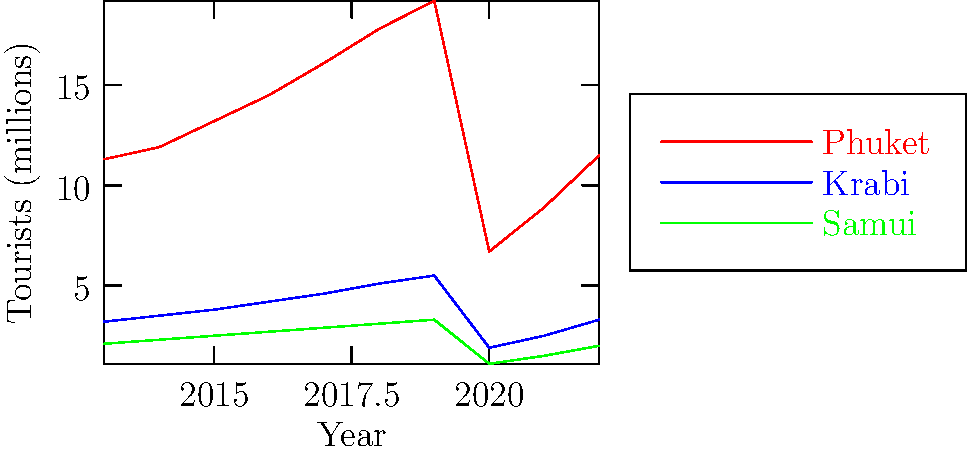Based on the tourism trends shown in the line graph for Thailand's coastal regions over the past decade, which destination appears to be recovering the fastest in terms of tourist numbers following the significant drop in 2020? To determine which destination is recovering the fastest after the 2020 drop, we need to analyze the slopes of the lines from 2020 to 2022 for each destination:

1. Phuket:
   - 2020: 6.7 million tourists
   - 2022: 11.5 million tourists
   - Increase: 4.8 million over 2 years
   - Rate of increase: 2.4 million per year

2. Krabi:
   - 2020: 1.9 million tourists
   - 2022: 3.3 million tourists
   - Increase: 1.4 million over 2 years
   - Rate of increase: 0.7 million per year

3. Samui:
   - 2020: 1.1 million tourists
   - 2022: 2.0 million tourists
   - Increase: 0.9 million over 2 years
   - Rate of increase: 0.45 million per year

Phuket has the steepest slope and the highest rate of increase at 2.4 million tourists per year, indicating the fastest recovery among the three destinations.
Answer: Phuket 